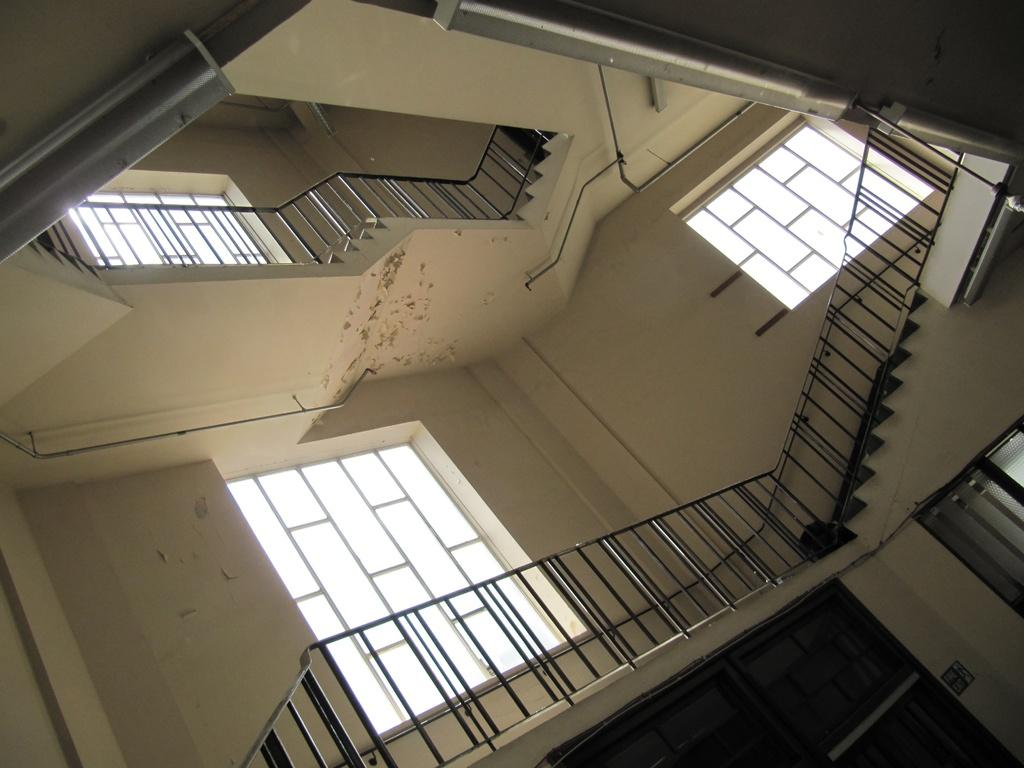What type of location is depicted in the image? The image shows an inside view of a building. What architectural feature can be seen in the background? There is a staircase visible in the background. What other elements are present in the background? There are windows and poles in the background. What type of authority figure can be seen in the image? There is no authority figure present in the image; it only shows an inside view of a building with a staircase, windows, and poles in the background. Can you tell me how many goats are visible in the image? There are no goats present in the image. 